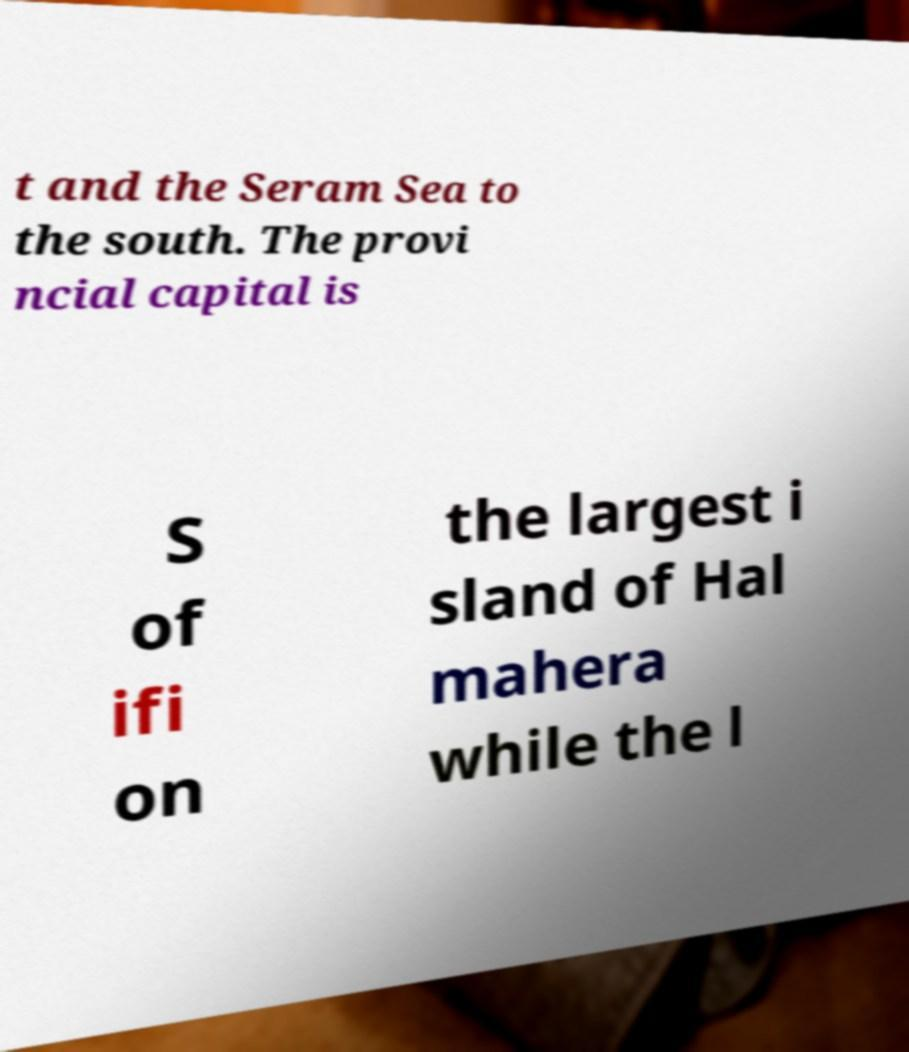For documentation purposes, I need the text within this image transcribed. Could you provide that? t and the Seram Sea to the south. The provi ncial capital is S of ifi on the largest i sland of Hal mahera while the l 